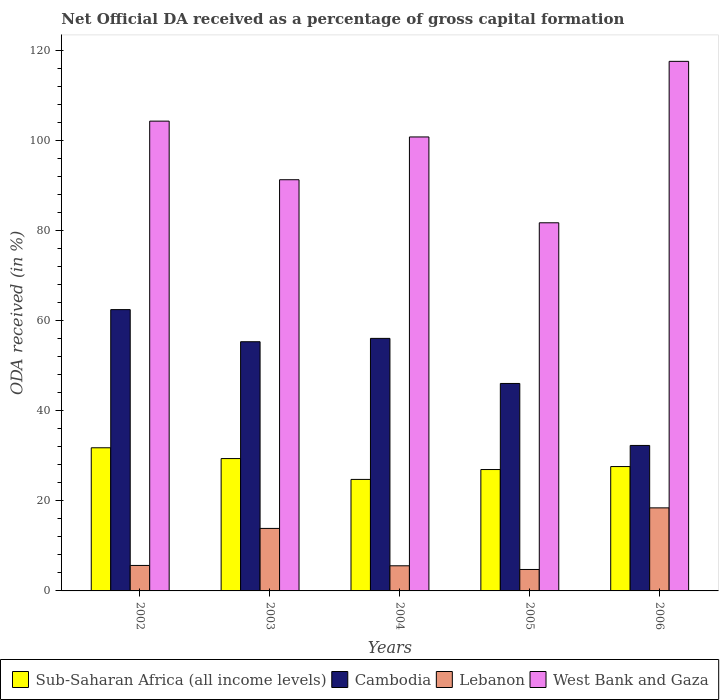How many different coloured bars are there?
Offer a very short reply. 4. Are the number of bars on each tick of the X-axis equal?
Your response must be concise. Yes. How many bars are there on the 3rd tick from the left?
Keep it short and to the point. 4. How many bars are there on the 1st tick from the right?
Give a very brief answer. 4. What is the label of the 1st group of bars from the left?
Make the answer very short. 2002. In how many cases, is the number of bars for a given year not equal to the number of legend labels?
Give a very brief answer. 0. What is the net ODA received in Cambodia in 2006?
Offer a terse response. 32.32. Across all years, what is the maximum net ODA received in Lebanon?
Provide a succinct answer. 18.45. Across all years, what is the minimum net ODA received in Lebanon?
Provide a short and direct response. 4.76. What is the total net ODA received in Lebanon in the graph?
Keep it short and to the point. 48.35. What is the difference between the net ODA received in Lebanon in 2002 and that in 2005?
Offer a very short reply. 0.9. What is the difference between the net ODA received in West Bank and Gaza in 2005 and the net ODA received in Lebanon in 2004?
Give a very brief answer. 76.2. What is the average net ODA received in West Bank and Gaza per year?
Ensure brevity in your answer.  99.2. In the year 2005, what is the difference between the net ODA received in West Bank and Gaza and net ODA received in Lebanon?
Provide a short and direct response. 77.02. In how many years, is the net ODA received in Cambodia greater than 8 %?
Your response must be concise. 5. What is the ratio of the net ODA received in Sub-Saharan Africa (all income levels) in 2004 to that in 2005?
Your response must be concise. 0.92. Is the net ODA received in Cambodia in 2002 less than that in 2005?
Offer a very short reply. No. What is the difference between the highest and the second highest net ODA received in Sub-Saharan Africa (all income levels)?
Your response must be concise. 2.4. What is the difference between the highest and the lowest net ODA received in West Bank and Gaza?
Provide a short and direct response. 35.87. Is the sum of the net ODA received in West Bank and Gaza in 2003 and 2004 greater than the maximum net ODA received in Lebanon across all years?
Provide a succinct answer. Yes. What does the 1st bar from the left in 2003 represents?
Ensure brevity in your answer.  Sub-Saharan Africa (all income levels). What does the 3rd bar from the right in 2002 represents?
Give a very brief answer. Cambodia. How many bars are there?
Your answer should be very brief. 20. Are all the bars in the graph horizontal?
Ensure brevity in your answer.  No. How many years are there in the graph?
Your answer should be very brief. 5. Are the values on the major ticks of Y-axis written in scientific E-notation?
Make the answer very short. No. Does the graph contain grids?
Provide a short and direct response. No. Where does the legend appear in the graph?
Ensure brevity in your answer.  Bottom left. How are the legend labels stacked?
Offer a very short reply. Horizontal. What is the title of the graph?
Provide a short and direct response. Net Official DA received as a percentage of gross capital formation. Does "Kenya" appear as one of the legend labels in the graph?
Offer a very short reply. No. What is the label or title of the X-axis?
Your answer should be compact. Years. What is the label or title of the Y-axis?
Your answer should be compact. ODA received (in %). What is the ODA received (in %) of Sub-Saharan Africa (all income levels) in 2002?
Your answer should be very brief. 31.8. What is the ODA received (in %) in Cambodia in 2002?
Keep it short and to the point. 62.49. What is the ODA received (in %) in Lebanon in 2002?
Your answer should be compact. 5.66. What is the ODA received (in %) of West Bank and Gaza in 2002?
Provide a short and direct response. 104.37. What is the ODA received (in %) in Sub-Saharan Africa (all income levels) in 2003?
Ensure brevity in your answer.  29.4. What is the ODA received (in %) in Cambodia in 2003?
Offer a very short reply. 55.36. What is the ODA received (in %) in Lebanon in 2003?
Provide a succinct answer. 13.89. What is the ODA received (in %) in West Bank and Gaza in 2003?
Your response must be concise. 91.35. What is the ODA received (in %) in Sub-Saharan Africa (all income levels) in 2004?
Make the answer very short. 24.77. What is the ODA received (in %) of Cambodia in 2004?
Offer a terse response. 56.1. What is the ODA received (in %) in Lebanon in 2004?
Your answer should be compact. 5.58. What is the ODA received (in %) in West Bank and Gaza in 2004?
Provide a succinct answer. 100.86. What is the ODA received (in %) of Sub-Saharan Africa (all income levels) in 2005?
Provide a short and direct response. 26.97. What is the ODA received (in %) in Cambodia in 2005?
Keep it short and to the point. 46.09. What is the ODA received (in %) of Lebanon in 2005?
Provide a short and direct response. 4.76. What is the ODA received (in %) in West Bank and Gaza in 2005?
Your response must be concise. 81.78. What is the ODA received (in %) of Sub-Saharan Africa (all income levels) in 2006?
Offer a very short reply. 27.63. What is the ODA received (in %) of Cambodia in 2006?
Your answer should be very brief. 32.32. What is the ODA received (in %) in Lebanon in 2006?
Offer a very short reply. 18.45. What is the ODA received (in %) of West Bank and Gaza in 2006?
Give a very brief answer. 117.65. Across all years, what is the maximum ODA received (in %) in Sub-Saharan Africa (all income levels)?
Offer a very short reply. 31.8. Across all years, what is the maximum ODA received (in %) of Cambodia?
Provide a succinct answer. 62.49. Across all years, what is the maximum ODA received (in %) in Lebanon?
Ensure brevity in your answer.  18.45. Across all years, what is the maximum ODA received (in %) in West Bank and Gaza?
Provide a short and direct response. 117.65. Across all years, what is the minimum ODA received (in %) of Sub-Saharan Africa (all income levels)?
Offer a terse response. 24.77. Across all years, what is the minimum ODA received (in %) in Cambodia?
Your response must be concise. 32.32. Across all years, what is the minimum ODA received (in %) in Lebanon?
Offer a terse response. 4.76. Across all years, what is the minimum ODA received (in %) of West Bank and Gaza?
Provide a short and direct response. 81.78. What is the total ODA received (in %) of Sub-Saharan Africa (all income levels) in the graph?
Ensure brevity in your answer.  140.57. What is the total ODA received (in %) of Cambodia in the graph?
Provide a succinct answer. 252.37. What is the total ODA received (in %) of Lebanon in the graph?
Your response must be concise. 48.35. What is the total ODA received (in %) in West Bank and Gaza in the graph?
Offer a very short reply. 496.01. What is the difference between the ODA received (in %) in Sub-Saharan Africa (all income levels) in 2002 and that in 2003?
Keep it short and to the point. 2.4. What is the difference between the ODA received (in %) of Cambodia in 2002 and that in 2003?
Provide a short and direct response. 7.13. What is the difference between the ODA received (in %) of Lebanon in 2002 and that in 2003?
Ensure brevity in your answer.  -8.23. What is the difference between the ODA received (in %) of West Bank and Gaza in 2002 and that in 2003?
Offer a terse response. 13.02. What is the difference between the ODA received (in %) in Sub-Saharan Africa (all income levels) in 2002 and that in 2004?
Provide a short and direct response. 7.03. What is the difference between the ODA received (in %) of Cambodia in 2002 and that in 2004?
Your answer should be compact. 6.39. What is the difference between the ODA received (in %) of Lebanon in 2002 and that in 2004?
Offer a terse response. 0.08. What is the difference between the ODA received (in %) in West Bank and Gaza in 2002 and that in 2004?
Provide a succinct answer. 3.51. What is the difference between the ODA received (in %) in Sub-Saharan Africa (all income levels) in 2002 and that in 2005?
Your answer should be compact. 4.83. What is the difference between the ODA received (in %) of Cambodia in 2002 and that in 2005?
Provide a succinct answer. 16.4. What is the difference between the ODA received (in %) in Lebanon in 2002 and that in 2005?
Your answer should be very brief. 0.9. What is the difference between the ODA received (in %) in West Bank and Gaza in 2002 and that in 2005?
Your answer should be very brief. 22.59. What is the difference between the ODA received (in %) of Sub-Saharan Africa (all income levels) in 2002 and that in 2006?
Provide a short and direct response. 4.17. What is the difference between the ODA received (in %) in Cambodia in 2002 and that in 2006?
Make the answer very short. 30.18. What is the difference between the ODA received (in %) of Lebanon in 2002 and that in 2006?
Your answer should be compact. -12.79. What is the difference between the ODA received (in %) in West Bank and Gaza in 2002 and that in 2006?
Your answer should be very brief. -13.28. What is the difference between the ODA received (in %) in Sub-Saharan Africa (all income levels) in 2003 and that in 2004?
Your answer should be very brief. 4.63. What is the difference between the ODA received (in %) in Cambodia in 2003 and that in 2004?
Offer a very short reply. -0.74. What is the difference between the ODA received (in %) in Lebanon in 2003 and that in 2004?
Provide a succinct answer. 8.3. What is the difference between the ODA received (in %) in West Bank and Gaza in 2003 and that in 2004?
Ensure brevity in your answer.  -9.51. What is the difference between the ODA received (in %) of Sub-Saharan Africa (all income levels) in 2003 and that in 2005?
Your answer should be very brief. 2.44. What is the difference between the ODA received (in %) of Cambodia in 2003 and that in 2005?
Provide a short and direct response. 9.27. What is the difference between the ODA received (in %) in Lebanon in 2003 and that in 2005?
Offer a terse response. 9.12. What is the difference between the ODA received (in %) in West Bank and Gaza in 2003 and that in 2005?
Give a very brief answer. 9.57. What is the difference between the ODA received (in %) of Sub-Saharan Africa (all income levels) in 2003 and that in 2006?
Your response must be concise. 1.77. What is the difference between the ODA received (in %) in Cambodia in 2003 and that in 2006?
Your response must be concise. 23.04. What is the difference between the ODA received (in %) in Lebanon in 2003 and that in 2006?
Ensure brevity in your answer.  -4.56. What is the difference between the ODA received (in %) in West Bank and Gaza in 2003 and that in 2006?
Your answer should be compact. -26.3. What is the difference between the ODA received (in %) of Sub-Saharan Africa (all income levels) in 2004 and that in 2005?
Your response must be concise. -2.19. What is the difference between the ODA received (in %) in Cambodia in 2004 and that in 2005?
Keep it short and to the point. 10.01. What is the difference between the ODA received (in %) in Lebanon in 2004 and that in 2005?
Make the answer very short. 0.82. What is the difference between the ODA received (in %) in West Bank and Gaza in 2004 and that in 2005?
Offer a terse response. 19.07. What is the difference between the ODA received (in %) in Sub-Saharan Africa (all income levels) in 2004 and that in 2006?
Provide a succinct answer. -2.86. What is the difference between the ODA received (in %) of Cambodia in 2004 and that in 2006?
Offer a very short reply. 23.79. What is the difference between the ODA received (in %) of Lebanon in 2004 and that in 2006?
Provide a short and direct response. -12.87. What is the difference between the ODA received (in %) in West Bank and Gaza in 2004 and that in 2006?
Your answer should be compact. -16.79. What is the difference between the ODA received (in %) in Sub-Saharan Africa (all income levels) in 2005 and that in 2006?
Offer a very short reply. -0.66. What is the difference between the ODA received (in %) of Cambodia in 2005 and that in 2006?
Keep it short and to the point. 13.77. What is the difference between the ODA received (in %) in Lebanon in 2005 and that in 2006?
Provide a short and direct response. -13.69. What is the difference between the ODA received (in %) of West Bank and Gaza in 2005 and that in 2006?
Provide a succinct answer. -35.87. What is the difference between the ODA received (in %) in Sub-Saharan Africa (all income levels) in 2002 and the ODA received (in %) in Cambodia in 2003?
Make the answer very short. -23.56. What is the difference between the ODA received (in %) of Sub-Saharan Africa (all income levels) in 2002 and the ODA received (in %) of Lebanon in 2003?
Offer a terse response. 17.91. What is the difference between the ODA received (in %) in Sub-Saharan Africa (all income levels) in 2002 and the ODA received (in %) in West Bank and Gaza in 2003?
Give a very brief answer. -59.55. What is the difference between the ODA received (in %) of Cambodia in 2002 and the ODA received (in %) of Lebanon in 2003?
Give a very brief answer. 48.61. What is the difference between the ODA received (in %) in Cambodia in 2002 and the ODA received (in %) in West Bank and Gaza in 2003?
Make the answer very short. -28.86. What is the difference between the ODA received (in %) in Lebanon in 2002 and the ODA received (in %) in West Bank and Gaza in 2003?
Give a very brief answer. -85.69. What is the difference between the ODA received (in %) in Sub-Saharan Africa (all income levels) in 2002 and the ODA received (in %) in Cambodia in 2004?
Provide a succinct answer. -24.3. What is the difference between the ODA received (in %) of Sub-Saharan Africa (all income levels) in 2002 and the ODA received (in %) of Lebanon in 2004?
Your answer should be very brief. 26.22. What is the difference between the ODA received (in %) in Sub-Saharan Africa (all income levels) in 2002 and the ODA received (in %) in West Bank and Gaza in 2004?
Ensure brevity in your answer.  -69.06. What is the difference between the ODA received (in %) in Cambodia in 2002 and the ODA received (in %) in Lebanon in 2004?
Provide a succinct answer. 56.91. What is the difference between the ODA received (in %) in Cambodia in 2002 and the ODA received (in %) in West Bank and Gaza in 2004?
Your response must be concise. -38.36. What is the difference between the ODA received (in %) in Lebanon in 2002 and the ODA received (in %) in West Bank and Gaza in 2004?
Keep it short and to the point. -95.2. What is the difference between the ODA received (in %) of Sub-Saharan Africa (all income levels) in 2002 and the ODA received (in %) of Cambodia in 2005?
Make the answer very short. -14.29. What is the difference between the ODA received (in %) in Sub-Saharan Africa (all income levels) in 2002 and the ODA received (in %) in Lebanon in 2005?
Offer a very short reply. 27.04. What is the difference between the ODA received (in %) in Sub-Saharan Africa (all income levels) in 2002 and the ODA received (in %) in West Bank and Gaza in 2005?
Ensure brevity in your answer.  -49.98. What is the difference between the ODA received (in %) in Cambodia in 2002 and the ODA received (in %) in Lebanon in 2005?
Offer a terse response. 57.73. What is the difference between the ODA received (in %) in Cambodia in 2002 and the ODA received (in %) in West Bank and Gaza in 2005?
Your response must be concise. -19.29. What is the difference between the ODA received (in %) of Lebanon in 2002 and the ODA received (in %) of West Bank and Gaza in 2005?
Give a very brief answer. -76.12. What is the difference between the ODA received (in %) in Sub-Saharan Africa (all income levels) in 2002 and the ODA received (in %) in Cambodia in 2006?
Your answer should be compact. -0.52. What is the difference between the ODA received (in %) of Sub-Saharan Africa (all income levels) in 2002 and the ODA received (in %) of Lebanon in 2006?
Keep it short and to the point. 13.35. What is the difference between the ODA received (in %) in Sub-Saharan Africa (all income levels) in 2002 and the ODA received (in %) in West Bank and Gaza in 2006?
Your response must be concise. -85.85. What is the difference between the ODA received (in %) in Cambodia in 2002 and the ODA received (in %) in Lebanon in 2006?
Your answer should be very brief. 44.04. What is the difference between the ODA received (in %) of Cambodia in 2002 and the ODA received (in %) of West Bank and Gaza in 2006?
Give a very brief answer. -55.16. What is the difference between the ODA received (in %) of Lebanon in 2002 and the ODA received (in %) of West Bank and Gaza in 2006?
Ensure brevity in your answer.  -111.99. What is the difference between the ODA received (in %) in Sub-Saharan Africa (all income levels) in 2003 and the ODA received (in %) in Cambodia in 2004?
Your response must be concise. -26.7. What is the difference between the ODA received (in %) of Sub-Saharan Africa (all income levels) in 2003 and the ODA received (in %) of Lebanon in 2004?
Provide a succinct answer. 23.82. What is the difference between the ODA received (in %) of Sub-Saharan Africa (all income levels) in 2003 and the ODA received (in %) of West Bank and Gaza in 2004?
Ensure brevity in your answer.  -71.45. What is the difference between the ODA received (in %) of Cambodia in 2003 and the ODA received (in %) of Lebanon in 2004?
Make the answer very short. 49.78. What is the difference between the ODA received (in %) in Cambodia in 2003 and the ODA received (in %) in West Bank and Gaza in 2004?
Offer a terse response. -45.5. What is the difference between the ODA received (in %) of Lebanon in 2003 and the ODA received (in %) of West Bank and Gaza in 2004?
Provide a short and direct response. -86.97. What is the difference between the ODA received (in %) of Sub-Saharan Africa (all income levels) in 2003 and the ODA received (in %) of Cambodia in 2005?
Your answer should be very brief. -16.69. What is the difference between the ODA received (in %) in Sub-Saharan Africa (all income levels) in 2003 and the ODA received (in %) in Lebanon in 2005?
Provide a short and direct response. 24.64. What is the difference between the ODA received (in %) in Sub-Saharan Africa (all income levels) in 2003 and the ODA received (in %) in West Bank and Gaza in 2005?
Your answer should be compact. -52.38. What is the difference between the ODA received (in %) of Cambodia in 2003 and the ODA received (in %) of Lebanon in 2005?
Your answer should be very brief. 50.6. What is the difference between the ODA received (in %) of Cambodia in 2003 and the ODA received (in %) of West Bank and Gaza in 2005?
Your answer should be very brief. -26.42. What is the difference between the ODA received (in %) of Lebanon in 2003 and the ODA received (in %) of West Bank and Gaza in 2005?
Provide a short and direct response. -67.9. What is the difference between the ODA received (in %) in Sub-Saharan Africa (all income levels) in 2003 and the ODA received (in %) in Cambodia in 2006?
Your response must be concise. -2.91. What is the difference between the ODA received (in %) in Sub-Saharan Africa (all income levels) in 2003 and the ODA received (in %) in Lebanon in 2006?
Your response must be concise. 10.95. What is the difference between the ODA received (in %) in Sub-Saharan Africa (all income levels) in 2003 and the ODA received (in %) in West Bank and Gaza in 2006?
Provide a short and direct response. -88.25. What is the difference between the ODA received (in %) in Cambodia in 2003 and the ODA received (in %) in Lebanon in 2006?
Your response must be concise. 36.91. What is the difference between the ODA received (in %) of Cambodia in 2003 and the ODA received (in %) of West Bank and Gaza in 2006?
Provide a succinct answer. -62.29. What is the difference between the ODA received (in %) in Lebanon in 2003 and the ODA received (in %) in West Bank and Gaza in 2006?
Your response must be concise. -103.76. What is the difference between the ODA received (in %) of Sub-Saharan Africa (all income levels) in 2004 and the ODA received (in %) of Cambodia in 2005?
Your response must be concise. -21.32. What is the difference between the ODA received (in %) of Sub-Saharan Africa (all income levels) in 2004 and the ODA received (in %) of Lebanon in 2005?
Ensure brevity in your answer.  20.01. What is the difference between the ODA received (in %) of Sub-Saharan Africa (all income levels) in 2004 and the ODA received (in %) of West Bank and Gaza in 2005?
Ensure brevity in your answer.  -57.01. What is the difference between the ODA received (in %) in Cambodia in 2004 and the ODA received (in %) in Lebanon in 2005?
Provide a short and direct response. 51.34. What is the difference between the ODA received (in %) of Cambodia in 2004 and the ODA received (in %) of West Bank and Gaza in 2005?
Your response must be concise. -25.68. What is the difference between the ODA received (in %) of Lebanon in 2004 and the ODA received (in %) of West Bank and Gaza in 2005?
Your answer should be very brief. -76.2. What is the difference between the ODA received (in %) in Sub-Saharan Africa (all income levels) in 2004 and the ODA received (in %) in Cambodia in 2006?
Offer a very short reply. -7.54. What is the difference between the ODA received (in %) in Sub-Saharan Africa (all income levels) in 2004 and the ODA received (in %) in Lebanon in 2006?
Keep it short and to the point. 6.32. What is the difference between the ODA received (in %) in Sub-Saharan Africa (all income levels) in 2004 and the ODA received (in %) in West Bank and Gaza in 2006?
Your answer should be very brief. -92.88. What is the difference between the ODA received (in %) in Cambodia in 2004 and the ODA received (in %) in Lebanon in 2006?
Your answer should be compact. 37.65. What is the difference between the ODA received (in %) in Cambodia in 2004 and the ODA received (in %) in West Bank and Gaza in 2006?
Your response must be concise. -61.55. What is the difference between the ODA received (in %) of Lebanon in 2004 and the ODA received (in %) of West Bank and Gaza in 2006?
Make the answer very short. -112.07. What is the difference between the ODA received (in %) in Sub-Saharan Africa (all income levels) in 2005 and the ODA received (in %) in Cambodia in 2006?
Make the answer very short. -5.35. What is the difference between the ODA received (in %) of Sub-Saharan Africa (all income levels) in 2005 and the ODA received (in %) of Lebanon in 2006?
Provide a short and direct response. 8.52. What is the difference between the ODA received (in %) in Sub-Saharan Africa (all income levels) in 2005 and the ODA received (in %) in West Bank and Gaza in 2006?
Your response must be concise. -90.68. What is the difference between the ODA received (in %) in Cambodia in 2005 and the ODA received (in %) in Lebanon in 2006?
Give a very brief answer. 27.64. What is the difference between the ODA received (in %) of Cambodia in 2005 and the ODA received (in %) of West Bank and Gaza in 2006?
Offer a very short reply. -71.56. What is the difference between the ODA received (in %) of Lebanon in 2005 and the ODA received (in %) of West Bank and Gaza in 2006?
Provide a succinct answer. -112.88. What is the average ODA received (in %) in Sub-Saharan Africa (all income levels) per year?
Offer a terse response. 28.11. What is the average ODA received (in %) in Cambodia per year?
Your response must be concise. 50.47. What is the average ODA received (in %) in Lebanon per year?
Provide a succinct answer. 9.67. What is the average ODA received (in %) of West Bank and Gaza per year?
Ensure brevity in your answer.  99.2. In the year 2002, what is the difference between the ODA received (in %) in Sub-Saharan Africa (all income levels) and ODA received (in %) in Cambodia?
Give a very brief answer. -30.69. In the year 2002, what is the difference between the ODA received (in %) in Sub-Saharan Africa (all income levels) and ODA received (in %) in Lebanon?
Provide a short and direct response. 26.14. In the year 2002, what is the difference between the ODA received (in %) in Sub-Saharan Africa (all income levels) and ODA received (in %) in West Bank and Gaza?
Provide a succinct answer. -72.57. In the year 2002, what is the difference between the ODA received (in %) of Cambodia and ODA received (in %) of Lebanon?
Offer a terse response. 56.83. In the year 2002, what is the difference between the ODA received (in %) in Cambodia and ODA received (in %) in West Bank and Gaza?
Your answer should be compact. -41.88. In the year 2002, what is the difference between the ODA received (in %) in Lebanon and ODA received (in %) in West Bank and Gaza?
Make the answer very short. -98.71. In the year 2003, what is the difference between the ODA received (in %) in Sub-Saharan Africa (all income levels) and ODA received (in %) in Cambodia?
Your response must be concise. -25.96. In the year 2003, what is the difference between the ODA received (in %) of Sub-Saharan Africa (all income levels) and ODA received (in %) of Lebanon?
Give a very brief answer. 15.52. In the year 2003, what is the difference between the ODA received (in %) in Sub-Saharan Africa (all income levels) and ODA received (in %) in West Bank and Gaza?
Offer a very short reply. -61.95. In the year 2003, what is the difference between the ODA received (in %) of Cambodia and ODA received (in %) of Lebanon?
Provide a succinct answer. 41.47. In the year 2003, what is the difference between the ODA received (in %) of Cambodia and ODA received (in %) of West Bank and Gaza?
Your answer should be compact. -35.99. In the year 2003, what is the difference between the ODA received (in %) of Lebanon and ODA received (in %) of West Bank and Gaza?
Offer a very short reply. -77.46. In the year 2004, what is the difference between the ODA received (in %) of Sub-Saharan Africa (all income levels) and ODA received (in %) of Cambodia?
Ensure brevity in your answer.  -31.33. In the year 2004, what is the difference between the ODA received (in %) in Sub-Saharan Africa (all income levels) and ODA received (in %) in Lebanon?
Your answer should be compact. 19.19. In the year 2004, what is the difference between the ODA received (in %) in Sub-Saharan Africa (all income levels) and ODA received (in %) in West Bank and Gaza?
Your answer should be compact. -76.08. In the year 2004, what is the difference between the ODA received (in %) in Cambodia and ODA received (in %) in Lebanon?
Offer a terse response. 50.52. In the year 2004, what is the difference between the ODA received (in %) of Cambodia and ODA received (in %) of West Bank and Gaza?
Keep it short and to the point. -44.75. In the year 2004, what is the difference between the ODA received (in %) of Lebanon and ODA received (in %) of West Bank and Gaza?
Your answer should be very brief. -95.27. In the year 2005, what is the difference between the ODA received (in %) of Sub-Saharan Africa (all income levels) and ODA received (in %) of Cambodia?
Provide a succinct answer. -19.12. In the year 2005, what is the difference between the ODA received (in %) in Sub-Saharan Africa (all income levels) and ODA received (in %) in Lebanon?
Give a very brief answer. 22.2. In the year 2005, what is the difference between the ODA received (in %) in Sub-Saharan Africa (all income levels) and ODA received (in %) in West Bank and Gaza?
Provide a short and direct response. -54.82. In the year 2005, what is the difference between the ODA received (in %) in Cambodia and ODA received (in %) in Lebanon?
Your answer should be compact. 41.33. In the year 2005, what is the difference between the ODA received (in %) of Cambodia and ODA received (in %) of West Bank and Gaza?
Ensure brevity in your answer.  -35.69. In the year 2005, what is the difference between the ODA received (in %) of Lebanon and ODA received (in %) of West Bank and Gaza?
Your answer should be compact. -77.02. In the year 2006, what is the difference between the ODA received (in %) of Sub-Saharan Africa (all income levels) and ODA received (in %) of Cambodia?
Your answer should be compact. -4.69. In the year 2006, what is the difference between the ODA received (in %) of Sub-Saharan Africa (all income levels) and ODA received (in %) of Lebanon?
Offer a terse response. 9.18. In the year 2006, what is the difference between the ODA received (in %) in Sub-Saharan Africa (all income levels) and ODA received (in %) in West Bank and Gaza?
Offer a terse response. -90.02. In the year 2006, what is the difference between the ODA received (in %) of Cambodia and ODA received (in %) of Lebanon?
Provide a short and direct response. 13.87. In the year 2006, what is the difference between the ODA received (in %) in Cambodia and ODA received (in %) in West Bank and Gaza?
Provide a short and direct response. -85.33. In the year 2006, what is the difference between the ODA received (in %) of Lebanon and ODA received (in %) of West Bank and Gaza?
Your answer should be very brief. -99.2. What is the ratio of the ODA received (in %) in Sub-Saharan Africa (all income levels) in 2002 to that in 2003?
Offer a very short reply. 1.08. What is the ratio of the ODA received (in %) in Cambodia in 2002 to that in 2003?
Your answer should be very brief. 1.13. What is the ratio of the ODA received (in %) in Lebanon in 2002 to that in 2003?
Your response must be concise. 0.41. What is the ratio of the ODA received (in %) in West Bank and Gaza in 2002 to that in 2003?
Provide a short and direct response. 1.14. What is the ratio of the ODA received (in %) of Sub-Saharan Africa (all income levels) in 2002 to that in 2004?
Your answer should be compact. 1.28. What is the ratio of the ODA received (in %) of Cambodia in 2002 to that in 2004?
Make the answer very short. 1.11. What is the ratio of the ODA received (in %) of Lebanon in 2002 to that in 2004?
Provide a succinct answer. 1.01. What is the ratio of the ODA received (in %) of West Bank and Gaza in 2002 to that in 2004?
Your answer should be compact. 1.03. What is the ratio of the ODA received (in %) in Sub-Saharan Africa (all income levels) in 2002 to that in 2005?
Give a very brief answer. 1.18. What is the ratio of the ODA received (in %) in Cambodia in 2002 to that in 2005?
Your answer should be compact. 1.36. What is the ratio of the ODA received (in %) in Lebanon in 2002 to that in 2005?
Offer a terse response. 1.19. What is the ratio of the ODA received (in %) in West Bank and Gaza in 2002 to that in 2005?
Provide a short and direct response. 1.28. What is the ratio of the ODA received (in %) in Sub-Saharan Africa (all income levels) in 2002 to that in 2006?
Offer a terse response. 1.15. What is the ratio of the ODA received (in %) in Cambodia in 2002 to that in 2006?
Provide a short and direct response. 1.93. What is the ratio of the ODA received (in %) of Lebanon in 2002 to that in 2006?
Offer a very short reply. 0.31. What is the ratio of the ODA received (in %) in West Bank and Gaza in 2002 to that in 2006?
Offer a terse response. 0.89. What is the ratio of the ODA received (in %) of Sub-Saharan Africa (all income levels) in 2003 to that in 2004?
Provide a short and direct response. 1.19. What is the ratio of the ODA received (in %) in Lebanon in 2003 to that in 2004?
Make the answer very short. 2.49. What is the ratio of the ODA received (in %) of West Bank and Gaza in 2003 to that in 2004?
Offer a very short reply. 0.91. What is the ratio of the ODA received (in %) of Sub-Saharan Africa (all income levels) in 2003 to that in 2005?
Offer a very short reply. 1.09. What is the ratio of the ODA received (in %) of Cambodia in 2003 to that in 2005?
Make the answer very short. 1.2. What is the ratio of the ODA received (in %) of Lebanon in 2003 to that in 2005?
Give a very brief answer. 2.91. What is the ratio of the ODA received (in %) in West Bank and Gaza in 2003 to that in 2005?
Your answer should be very brief. 1.12. What is the ratio of the ODA received (in %) of Sub-Saharan Africa (all income levels) in 2003 to that in 2006?
Offer a very short reply. 1.06. What is the ratio of the ODA received (in %) of Cambodia in 2003 to that in 2006?
Your answer should be compact. 1.71. What is the ratio of the ODA received (in %) of Lebanon in 2003 to that in 2006?
Make the answer very short. 0.75. What is the ratio of the ODA received (in %) in West Bank and Gaza in 2003 to that in 2006?
Offer a terse response. 0.78. What is the ratio of the ODA received (in %) in Sub-Saharan Africa (all income levels) in 2004 to that in 2005?
Your answer should be compact. 0.92. What is the ratio of the ODA received (in %) in Cambodia in 2004 to that in 2005?
Ensure brevity in your answer.  1.22. What is the ratio of the ODA received (in %) of Lebanon in 2004 to that in 2005?
Your response must be concise. 1.17. What is the ratio of the ODA received (in %) of West Bank and Gaza in 2004 to that in 2005?
Make the answer very short. 1.23. What is the ratio of the ODA received (in %) of Sub-Saharan Africa (all income levels) in 2004 to that in 2006?
Keep it short and to the point. 0.9. What is the ratio of the ODA received (in %) in Cambodia in 2004 to that in 2006?
Offer a terse response. 1.74. What is the ratio of the ODA received (in %) of Lebanon in 2004 to that in 2006?
Ensure brevity in your answer.  0.3. What is the ratio of the ODA received (in %) of West Bank and Gaza in 2004 to that in 2006?
Ensure brevity in your answer.  0.86. What is the ratio of the ODA received (in %) in Cambodia in 2005 to that in 2006?
Your response must be concise. 1.43. What is the ratio of the ODA received (in %) of Lebanon in 2005 to that in 2006?
Give a very brief answer. 0.26. What is the ratio of the ODA received (in %) in West Bank and Gaza in 2005 to that in 2006?
Keep it short and to the point. 0.7. What is the difference between the highest and the second highest ODA received (in %) of Sub-Saharan Africa (all income levels)?
Keep it short and to the point. 2.4. What is the difference between the highest and the second highest ODA received (in %) in Cambodia?
Offer a terse response. 6.39. What is the difference between the highest and the second highest ODA received (in %) of Lebanon?
Give a very brief answer. 4.56. What is the difference between the highest and the second highest ODA received (in %) in West Bank and Gaza?
Keep it short and to the point. 13.28. What is the difference between the highest and the lowest ODA received (in %) in Sub-Saharan Africa (all income levels)?
Offer a very short reply. 7.03. What is the difference between the highest and the lowest ODA received (in %) in Cambodia?
Ensure brevity in your answer.  30.18. What is the difference between the highest and the lowest ODA received (in %) of Lebanon?
Offer a very short reply. 13.69. What is the difference between the highest and the lowest ODA received (in %) in West Bank and Gaza?
Provide a succinct answer. 35.87. 